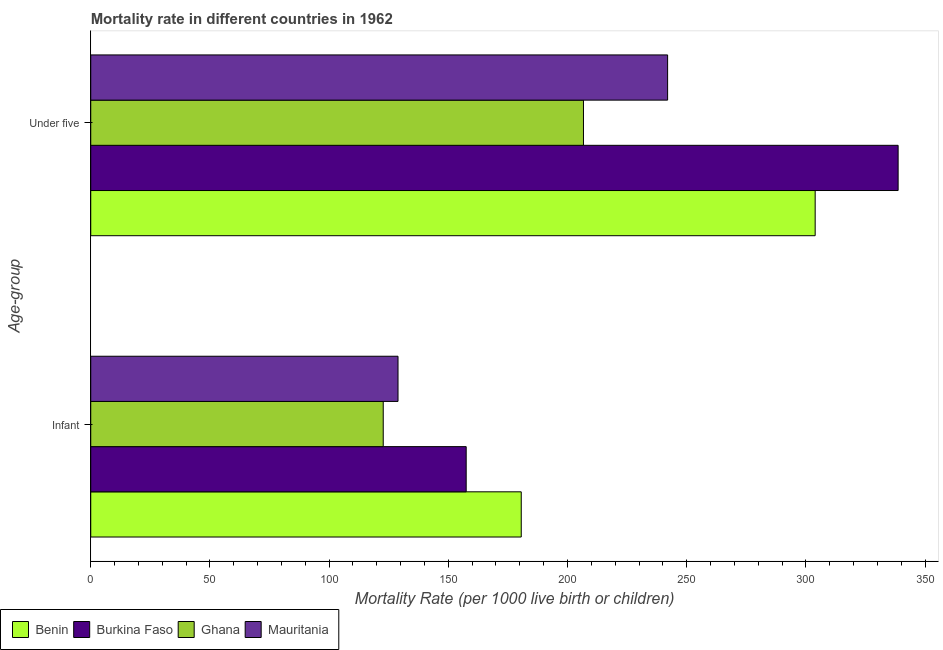How many different coloured bars are there?
Your response must be concise. 4. Are the number of bars per tick equal to the number of legend labels?
Offer a terse response. Yes. What is the label of the 2nd group of bars from the top?
Offer a very short reply. Infant. What is the under-5 mortality rate in Burkina Faso?
Your response must be concise. 338.7. Across all countries, what is the maximum under-5 mortality rate?
Keep it short and to the point. 338.7. Across all countries, what is the minimum under-5 mortality rate?
Provide a short and direct response. 206.7. In which country was the infant mortality rate maximum?
Your response must be concise. Benin. In which country was the infant mortality rate minimum?
Offer a terse response. Ghana. What is the total infant mortality rate in the graph?
Give a very brief answer. 589.7. What is the difference between the infant mortality rate in Benin and that in Ghana?
Give a very brief answer. 57.9. What is the difference between the under-5 mortality rate in Benin and the infant mortality rate in Burkina Faso?
Make the answer very short. 146.4. What is the average infant mortality rate per country?
Your answer should be compact. 147.43. What is the difference between the under-5 mortality rate and infant mortality rate in Mauritania?
Keep it short and to the point. 113.1. What is the ratio of the infant mortality rate in Ghana to that in Burkina Faso?
Your answer should be compact. 0.78. Is the infant mortality rate in Burkina Faso less than that in Mauritania?
Offer a terse response. No. What does the 2nd bar from the top in Under five represents?
Provide a short and direct response. Ghana. What does the 3rd bar from the bottom in Infant represents?
Provide a succinct answer. Ghana. What is the difference between two consecutive major ticks on the X-axis?
Your answer should be compact. 50. Does the graph contain any zero values?
Your answer should be very brief. No. Where does the legend appear in the graph?
Provide a succinct answer. Bottom left. How many legend labels are there?
Give a very brief answer. 4. What is the title of the graph?
Offer a very short reply. Mortality rate in different countries in 1962. What is the label or title of the X-axis?
Give a very brief answer. Mortality Rate (per 1000 live birth or children). What is the label or title of the Y-axis?
Make the answer very short. Age-group. What is the Mortality Rate (per 1000 live birth or children) in Benin in Infant?
Offer a very short reply. 180.6. What is the Mortality Rate (per 1000 live birth or children) in Burkina Faso in Infant?
Your answer should be very brief. 157.5. What is the Mortality Rate (per 1000 live birth or children) in Ghana in Infant?
Your answer should be very brief. 122.7. What is the Mortality Rate (per 1000 live birth or children) of Mauritania in Infant?
Provide a succinct answer. 128.9. What is the Mortality Rate (per 1000 live birth or children) in Benin in Under five?
Your answer should be very brief. 303.9. What is the Mortality Rate (per 1000 live birth or children) of Burkina Faso in Under five?
Ensure brevity in your answer.  338.7. What is the Mortality Rate (per 1000 live birth or children) in Ghana in Under five?
Ensure brevity in your answer.  206.7. What is the Mortality Rate (per 1000 live birth or children) of Mauritania in Under five?
Your answer should be compact. 242. Across all Age-group, what is the maximum Mortality Rate (per 1000 live birth or children) in Benin?
Offer a terse response. 303.9. Across all Age-group, what is the maximum Mortality Rate (per 1000 live birth or children) of Burkina Faso?
Keep it short and to the point. 338.7. Across all Age-group, what is the maximum Mortality Rate (per 1000 live birth or children) of Ghana?
Give a very brief answer. 206.7. Across all Age-group, what is the maximum Mortality Rate (per 1000 live birth or children) in Mauritania?
Your answer should be compact. 242. Across all Age-group, what is the minimum Mortality Rate (per 1000 live birth or children) in Benin?
Ensure brevity in your answer.  180.6. Across all Age-group, what is the minimum Mortality Rate (per 1000 live birth or children) in Burkina Faso?
Your answer should be very brief. 157.5. Across all Age-group, what is the minimum Mortality Rate (per 1000 live birth or children) of Ghana?
Keep it short and to the point. 122.7. Across all Age-group, what is the minimum Mortality Rate (per 1000 live birth or children) in Mauritania?
Offer a terse response. 128.9. What is the total Mortality Rate (per 1000 live birth or children) in Benin in the graph?
Your response must be concise. 484.5. What is the total Mortality Rate (per 1000 live birth or children) of Burkina Faso in the graph?
Keep it short and to the point. 496.2. What is the total Mortality Rate (per 1000 live birth or children) in Ghana in the graph?
Give a very brief answer. 329.4. What is the total Mortality Rate (per 1000 live birth or children) in Mauritania in the graph?
Give a very brief answer. 370.9. What is the difference between the Mortality Rate (per 1000 live birth or children) of Benin in Infant and that in Under five?
Ensure brevity in your answer.  -123.3. What is the difference between the Mortality Rate (per 1000 live birth or children) of Burkina Faso in Infant and that in Under five?
Offer a terse response. -181.2. What is the difference between the Mortality Rate (per 1000 live birth or children) of Ghana in Infant and that in Under five?
Provide a short and direct response. -84. What is the difference between the Mortality Rate (per 1000 live birth or children) in Mauritania in Infant and that in Under five?
Offer a very short reply. -113.1. What is the difference between the Mortality Rate (per 1000 live birth or children) of Benin in Infant and the Mortality Rate (per 1000 live birth or children) of Burkina Faso in Under five?
Your answer should be compact. -158.1. What is the difference between the Mortality Rate (per 1000 live birth or children) of Benin in Infant and the Mortality Rate (per 1000 live birth or children) of Ghana in Under five?
Keep it short and to the point. -26.1. What is the difference between the Mortality Rate (per 1000 live birth or children) in Benin in Infant and the Mortality Rate (per 1000 live birth or children) in Mauritania in Under five?
Your answer should be very brief. -61.4. What is the difference between the Mortality Rate (per 1000 live birth or children) of Burkina Faso in Infant and the Mortality Rate (per 1000 live birth or children) of Ghana in Under five?
Your response must be concise. -49.2. What is the difference between the Mortality Rate (per 1000 live birth or children) of Burkina Faso in Infant and the Mortality Rate (per 1000 live birth or children) of Mauritania in Under five?
Provide a succinct answer. -84.5. What is the difference between the Mortality Rate (per 1000 live birth or children) in Ghana in Infant and the Mortality Rate (per 1000 live birth or children) in Mauritania in Under five?
Provide a succinct answer. -119.3. What is the average Mortality Rate (per 1000 live birth or children) of Benin per Age-group?
Make the answer very short. 242.25. What is the average Mortality Rate (per 1000 live birth or children) of Burkina Faso per Age-group?
Provide a succinct answer. 248.1. What is the average Mortality Rate (per 1000 live birth or children) of Ghana per Age-group?
Your response must be concise. 164.7. What is the average Mortality Rate (per 1000 live birth or children) in Mauritania per Age-group?
Provide a short and direct response. 185.45. What is the difference between the Mortality Rate (per 1000 live birth or children) of Benin and Mortality Rate (per 1000 live birth or children) of Burkina Faso in Infant?
Make the answer very short. 23.1. What is the difference between the Mortality Rate (per 1000 live birth or children) of Benin and Mortality Rate (per 1000 live birth or children) of Ghana in Infant?
Your response must be concise. 57.9. What is the difference between the Mortality Rate (per 1000 live birth or children) in Benin and Mortality Rate (per 1000 live birth or children) in Mauritania in Infant?
Offer a terse response. 51.7. What is the difference between the Mortality Rate (per 1000 live birth or children) in Burkina Faso and Mortality Rate (per 1000 live birth or children) in Ghana in Infant?
Offer a very short reply. 34.8. What is the difference between the Mortality Rate (per 1000 live birth or children) of Burkina Faso and Mortality Rate (per 1000 live birth or children) of Mauritania in Infant?
Offer a very short reply. 28.6. What is the difference between the Mortality Rate (per 1000 live birth or children) in Benin and Mortality Rate (per 1000 live birth or children) in Burkina Faso in Under five?
Give a very brief answer. -34.8. What is the difference between the Mortality Rate (per 1000 live birth or children) in Benin and Mortality Rate (per 1000 live birth or children) in Ghana in Under five?
Your answer should be very brief. 97.2. What is the difference between the Mortality Rate (per 1000 live birth or children) of Benin and Mortality Rate (per 1000 live birth or children) of Mauritania in Under five?
Provide a short and direct response. 61.9. What is the difference between the Mortality Rate (per 1000 live birth or children) in Burkina Faso and Mortality Rate (per 1000 live birth or children) in Ghana in Under five?
Offer a very short reply. 132. What is the difference between the Mortality Rate (per 1000 live birth or children) of Burkina Faso and Mortality Rate (per 1000 live birth or children) of Mauritania in Under five?
Your response must be concise. 96.7. What is the difference between the Mortality Rate (per 1000 live birth or children) in Ghana and Mortality Rate (per 1000 live birth or children) in Mauritania in Under five?
Make the answer very short. -35.3. What is the ratio of the Mortality Rate (per 1000 live birth or children) of Benin in Infant to that in Under five?
Give a very brief answer. 0.59. What is the ratio of the Mortality Rate (per 1000 live birth or children) in Burkina Faso in Infant to that in Under five?
Your answer should be compact. 0.47. What is the ratio of the Mortality Rate (per 1000 live birth or children) of Ghana in Infant to that in Under five?
Provide a short and direct response. 0.59. What is the ratio of the Mortality Rate (per 1000 live birth or children) in Mauritania in Infant to that in Under five?
Keep it short and to the point. 0.53. What is the difference between the highest and the second highest Mortality Rate (per 1000 live birth or children) in Benin?
Keep it short and to the point. 123.3. What is the difference between the highest and the second highest Mortality Rate (per 1000 live birth or children) of Burkina Faso?
Keep it short and to the point. 181.2. What is the difference between the highest and the second highest Mortality Rate (per 1000 live birth or children) of Ghana?
Offer a terse response. 84. What is the difference between the highest and the second highest Mortality Rate (per 1000 live birth or children) in Mauritania?
Make the answer very short. 113.1. What is the difference between the highest and the lowest Mortality Rate (per 1000 live birth or children) in Benin?
Keep it short and to the point. 123.3. What is the difference between the highest and the lowest Mortality Rate (per 1000 live birth or children) in Burkina Faso?
Keep it short and to the point. 181.2. What is the difference between the highest and the lowest Mortality Rate (per 1000 live birth or children) in Mauritania?
Make the answer very short. 113.1. 